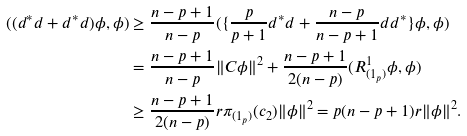Convert formula to latex. <formula><loc_0><loc_0><loc_500><loc_500>( ( d ^ { \ast } d + d ^ { \ast } d ) \phi , \phi ) & \geq \frac { n - p + 1 } { n - p } ( \{ \frac { p } { p + 1 } d ^ { \ast } d + \frac { n - p } { n - p + 1 } d d ^ { \ast } \} \phi , \phi ) \\ & = \frac { n - p + 1 } { n - p } \| C \phi \| ^ { 2 } + \frac { n - p + 1 } { 2 ( n - p ) } ( R _ { ( 1 _ { p } ) } ^ { 1 } \phi , \phi ) \\ & \geq \frac { n - p + 1 } { 2 ( n - p ) } r \pi _ { ( 1 _ { p } ) } ( c _ { 2 } ) \| \phi \| ^ { 2 } = p ( n - p + 1 ) r \| \phi \| ^ { 2 } .</formula> 